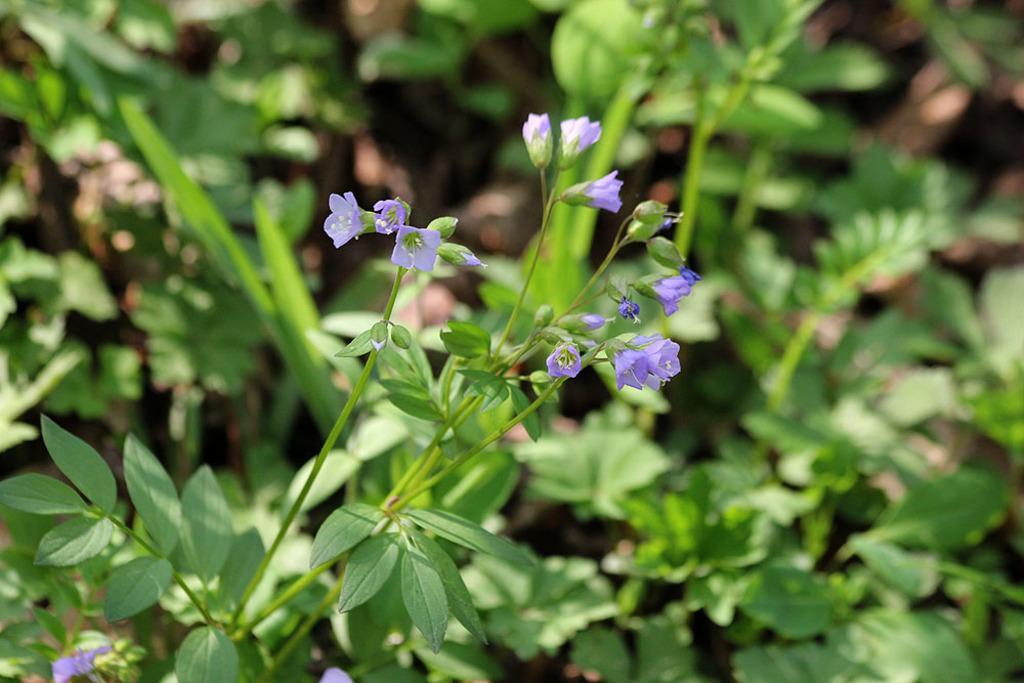Describe this image in one or two sentences. In the foreground of the picture I can see the flowering plant. In the background, I can see the green plants. 